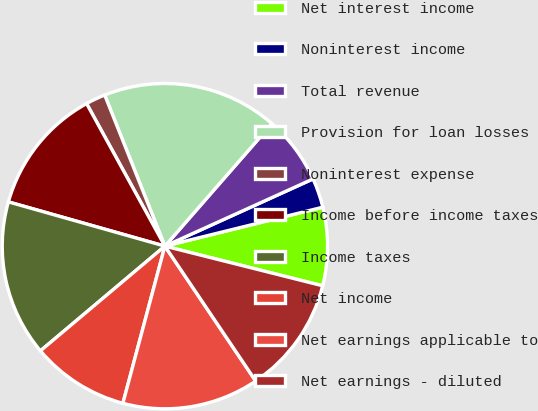<chart> <loc_0><loc_0><loc_500><loc_500><pie_chart><fcel>Net interest income<fcel>Noninterest income<fcel>Total revenue<fcel>Provision for loan losses<fcel>Noninterest expense<fcel>Income before income taxes<fcel>Income taxes<fcel>Net income<fcel>Net earnings applicable to<fcel>Net earnings - diluted<nl><fcel>7.77%<fcel>2.93%<fcel>6.8%<fcel>17.46%<fcel>1.96%<fcel>12.62%<fcel>15.52%<fcel>9.71%<fcel>13.59%<fcel>11.65%<nl></chart> 